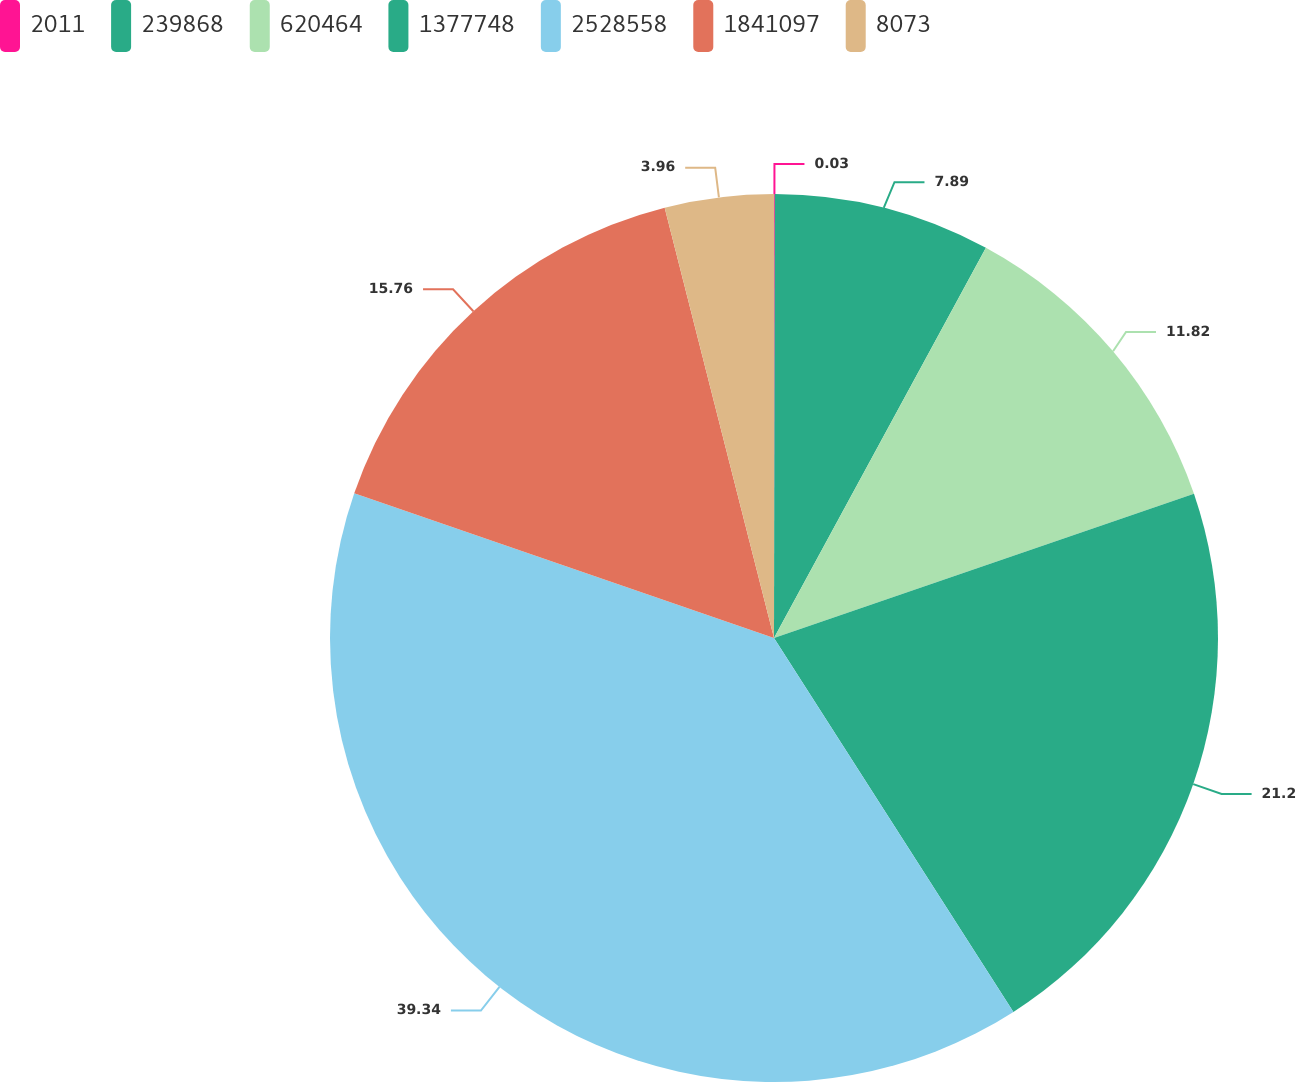Convert chart. <chart><loc_0><loc_0><loc_500><loc_500><pie_chart><fcel>2011<fcel>239868<fcel>620464<fcel>1377748<fcel>2528558<fcel>1841097<fcel>8073<nl><fcel>0.03%<fcel>7.89%<fcel>11.82%<fcel>21.2%<fcel>39.35%<fcel>15.76%<fcel>3.96%<nl></chart> 